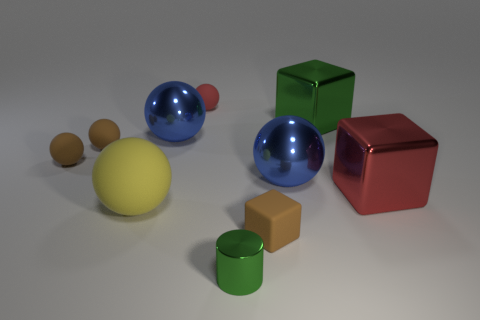Subtract all brown balls. How many balls are left? 4 Subtract all metal balls. How many balls are left? 4 Subtract all gray spheres. Subtract all gray cylinders. How many spheres are left? 6 Subtract all balls. How many objects are left? 4 Add 6 blue objects. How many blue objects are left? 8 Add 6 small green cylinders. How many small green cylinders exist? 7 Subtract 1 green cylinders. How many objects are left? 9 Subtract all large blue shiny balls. Subtract all red shiny cubes. How many objects are left? 7 